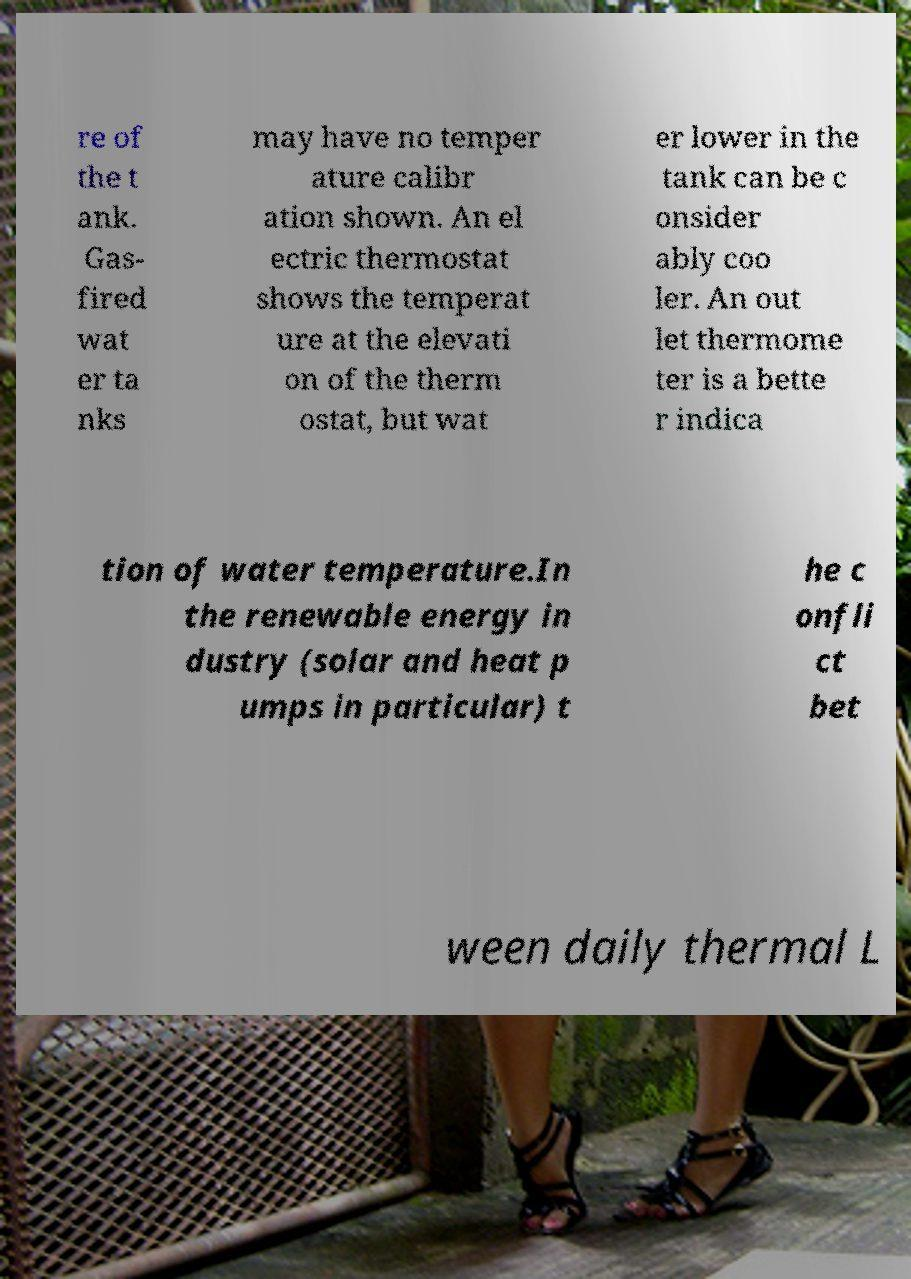Could you assist in decoding the text presented in this image and type it out clearly? re of the t ank. Gas- fired wat er ta nks may have no temper ature calibr ation shown. An el ectric thermostat shows the temperat ure at the elevati on of the therm ostat, but wat er lower in the tank can be c onsider ably coo ler. An out let thermome ter is a bette r indica tion of water temperature.In the renewable energy in dustry (solar and heat p umps in particular) t he c onfli ct bet ween daily thermal L 